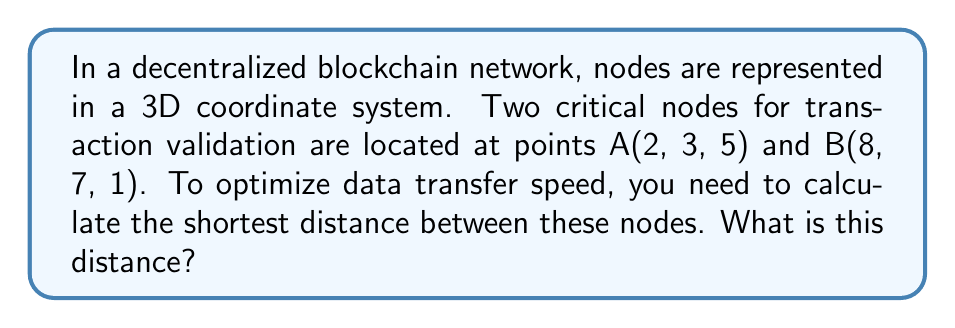Teach me how to tackle this problem. To find the shortest distance between two points in 3D space, we can use the distance formula derived from the Pythagorean theorem in three dimensions. The formula is:

$$d = \sqrt{(x_2 - x_1)^2 + (y_2 - y_1)^2 + (z_2 - z_1)^2}$$

Where $(x_1, y_1, z_1)$ are the coordinates of the first point and $(x_2, y_2, z_2)$ are the coordinates of the second point.

Given:
Point A(2, 3, 5)
Point B(8, 7, 1)

Let's substitute these values into our formula:

$$\begin{aligned}
d &= \sqrt{(8 - 2)^2 + (7 - 3)^2 + (1 - 5)^2} \\
&= \sqrt{6^2 + 4^2 + (-4)^2} \\
&= \sqrt{36 + 16 + 16} \\
&= \sqrt{68} \\
&= 2\sqrt{17}
\end{aligned}$$

[asy]
import three;

currentprojection=perspective(6,3,2);
size(200);

draw(O--6X,gray+dashed);
draw(O--6Y,gray+dashed);
draw(O--6Z,gray+dashed);

dot("A(2,3,5)",(2,3,5),N);
dot("B(8,7,1)",(8,7,1),N);

draw((2,3,5)--(8,7,1),red);
[/asy]

This distance represents the optimal path for data transfer between the two nodes in the blockchain network, ensuring the fastest possible transaction validation process.
Answer: $2\sqrt{17}$ units 